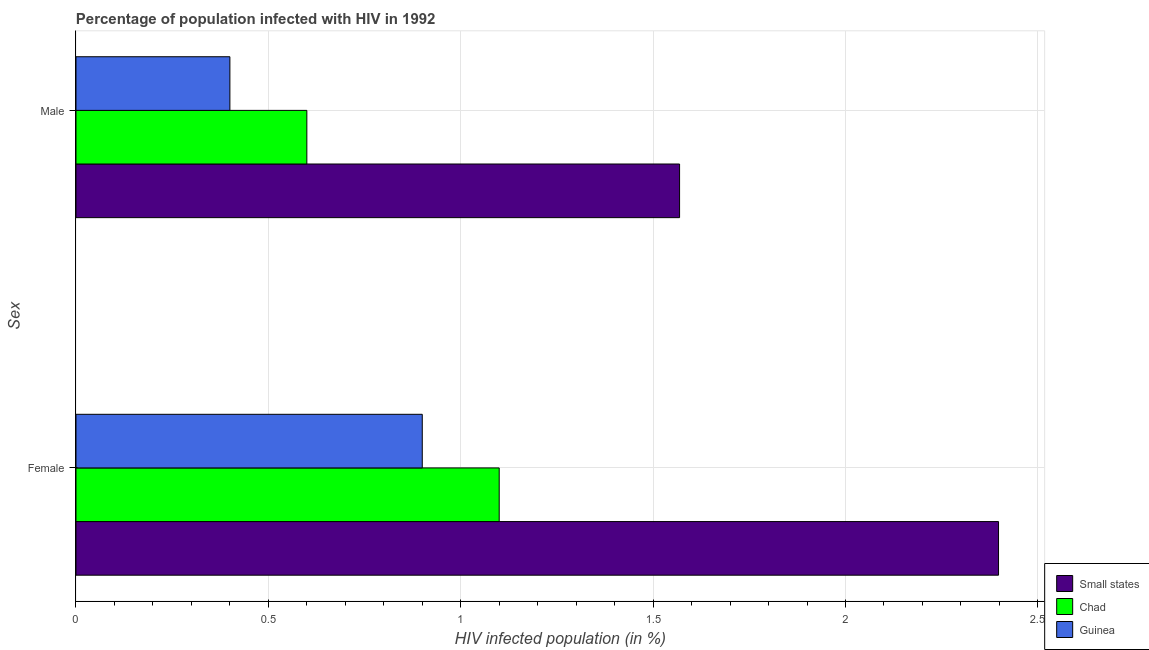How many groups of bars are there?
Keep it short and to the point. 2. Across all countries, what is the maximum percentage of females who are infected with hiv?
Your response must be concise. 2.4. Across all countries, what is the minimum percentage of females who are infected with hiv?
Offer a terse response. 0.9. In which country was the percentage of males who are infected with hiv maximum?
Provide a succinct answer. Small states. In which country was the percentage of males who are infected with hiv minimum?
Make the answer very short. Guinea. What is the total percentage of males who are infected with hiv in the graph?
Your answer should be compact. 2.57. What is the difference between the percentage of males who are infected with hiv in Chad and that in Small states?
Your answer should be compact. -0.97. What is the difference between the percentage of females who are infected with hiv in Small states and the percentage of males who are infected with hiv in Guinea?
Your response must be concise. 2. What is the average percentage of females who are infected with hiv per country?
Ensure brevity in your answer.  1.47. What is the ratio of the percentage of males who are infected with hiv in Guinea to that in Small states?
Provide a short and direct response. 0.25. Is the percentage of females who are infected with hiv in Small states less than that in Chad?
Your response must be concise. No. What does the 3rd bar from the top in Female represents?
Offer a terse response. Small states. What does the 3rd bar from the bottom in Female represents?
Make the answer very short. Guinea. How many countries are there in the graph?
Provide a succinct answer. 3. What is the difference between two consecutive major ticks on the X-axis?
Provide a short and direct response. 0.5. Are the values on the major ticks of X-axis written in scientific E-notation?
Your answer should be very brief. No. Does the graph contain any zero values?
Offer a terse response. No. How are the legend labels stacked?
Give a very brief answer. Vertical. What is the title of the graph?
Make the answer very short. Percentage of population infected with HIV in 1992. Does "Angola" appear as one of the legend labels in the graph?
Offer a terse response. No. What is the label or title of the X-axis?
Give a very brief answer. HIV infected population (in %). What is the label or title of the Y-axis?
Offer a terse response. Sex. What is the HIV infected population (in %) in Small states in Female?
Offer a terse response. 2.4. What is the HIV infected population (in %) in Guinea in Female?
Your response must be concise. 0.9. What is the HIV infected population (in %) of Small states in Male?
Provide a succinct answer. 1.57. What is the HIV infected population (in %) in Guinea in Male?
Your answer should be compact. 0.4. Across all Sex, what is the maximum HIV infected population (in %) of Small states?
Keep it short and to the point. 2.4. Across all Sex, what is the minimum HIV infected population (in %) of Small states?
Give a very brief answer. 1.57. What is the total HIV infected population (in %) in Small states in the graph?
Provide a succinct answer. 3.97. What is the total HIV infected population (in %) in Guinea in the graph?
Your response must be concise. 1.3. What is the difference between the HIV infected population (in %) in Small states in Female and that in Male?
Provide a succinct answer. 0.83. What is the difference between the HIV infected population (in %) in Guinea in Female and that in Male?
Your response must be concise. 0.5. What is the difference between the HIV infected population (in %) of Small states in Female and the HIV infected population (in %) of Chad in Male?
Ensure brevity in your answer.  1.8. What is the difference between the HIV infected population (in %) in Small states in Female and the HIV infected population (in %) in Guinea in Male?
Offer a terse response. 2. What is the difference between the HIV infected population (in %) in Chad in Female and the HIV infected population (in %) in Guinea in Male?
Your response must be concise. 0.7. What is the average HIV infected population (in %) of Small states per Sex?
Provide a short and direct response. 1.98. What is the average HIV infected population (in %) of Guinea per Sex?
Offer a very short reply. 0.65. What is the difference between the HIV infected population (in %) of Small states and HIV infected population (in %) of Chad in Female?
Provide a short and direct response. 1.3. What is the difference between the HIV infected population (in %) in Small states and HIV infected population (in %) in Guinea in Female?
Provide a short and direct response. 1.5. What is the difference between the HIV infected population (in %) in Chad and HIV infected population (in %) in Guinea in Female?
Your response must be concise. 0.2. What is the difference between the HIV infected population (in %) of Small states and HIV infected population (in %) of Chad in Male?
Your answer should be compact. 0.97. What is the difference between the HIV infected population (in %) of Small states and HIV infected population (in %) of Guinea in Male?
Provide a short and direct response. 1.17. What is the ratio of the HIV infected population (in %) in Small states in Female to that in Male?
Give a very brief answer. 1.53. What is the ratio of the HIV infected population (in %) in Chad in Female to that in Male?
Your answer should be very brief. 1.83. What is the ratio of the HIV infected population (in %) in Guinea in Female to that in Male?
Make the answer very short. 2.25. What is the difference between the highest and the second highest HIV infected population (in %) of Small states?
Keep it short and to the point. 0.83. What is the difference between the highest and the second highest HIV infected population (in %) of Guinea?
Offer a very short reply. 0.5. What is the difference between the highest and the lowest HIV infected population (in %) of Small states?
Your answer should be very brief. 0.83. What is the difference between the highest and the lowest HIV infected population (in %) of Chad?
Ensure brevity in your answer.  0.5. What is the difference between the highest and the lowest HIV infected population (in %) in Guinea?
Provide a succinct answer. 0.5. 